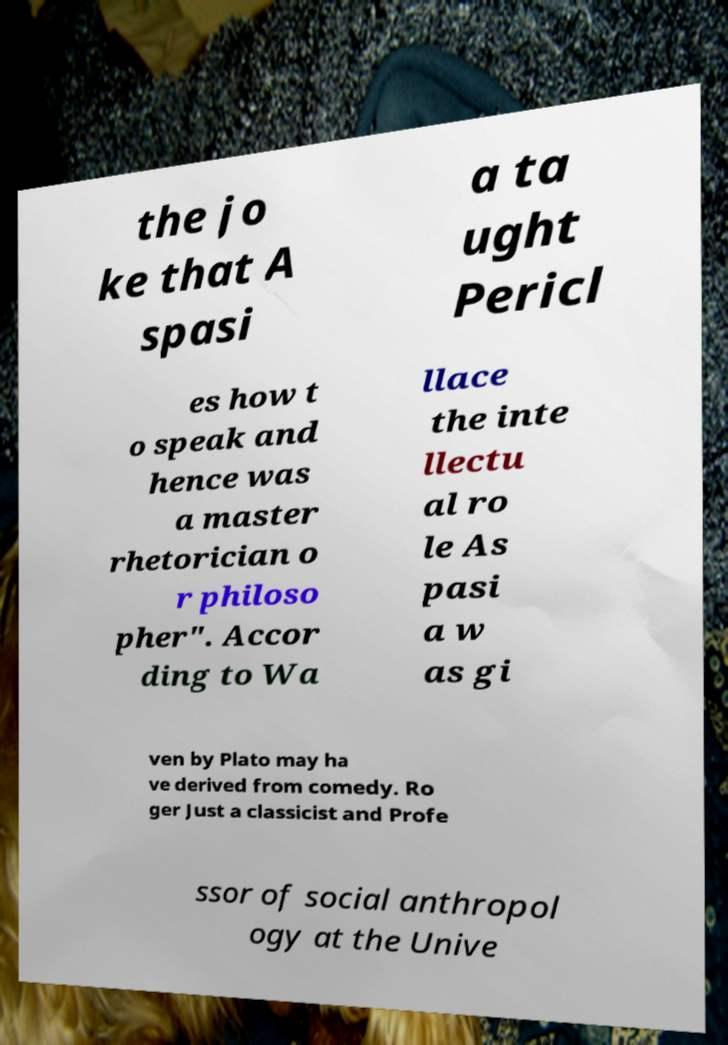Please read and relay the text visible in this image. What does it say? the jo ke that A spasi a ta ught Pericl es how t o speak and hence was a master rhetorician o r philoso pher". Accor ding to Wa llace the inte llectu al ro le As pasi a w as gi ven by Plato may ha ve derived from comedy. Ro ger Just a classicist and Profe ssor of social anthropol ogy at the Unive 